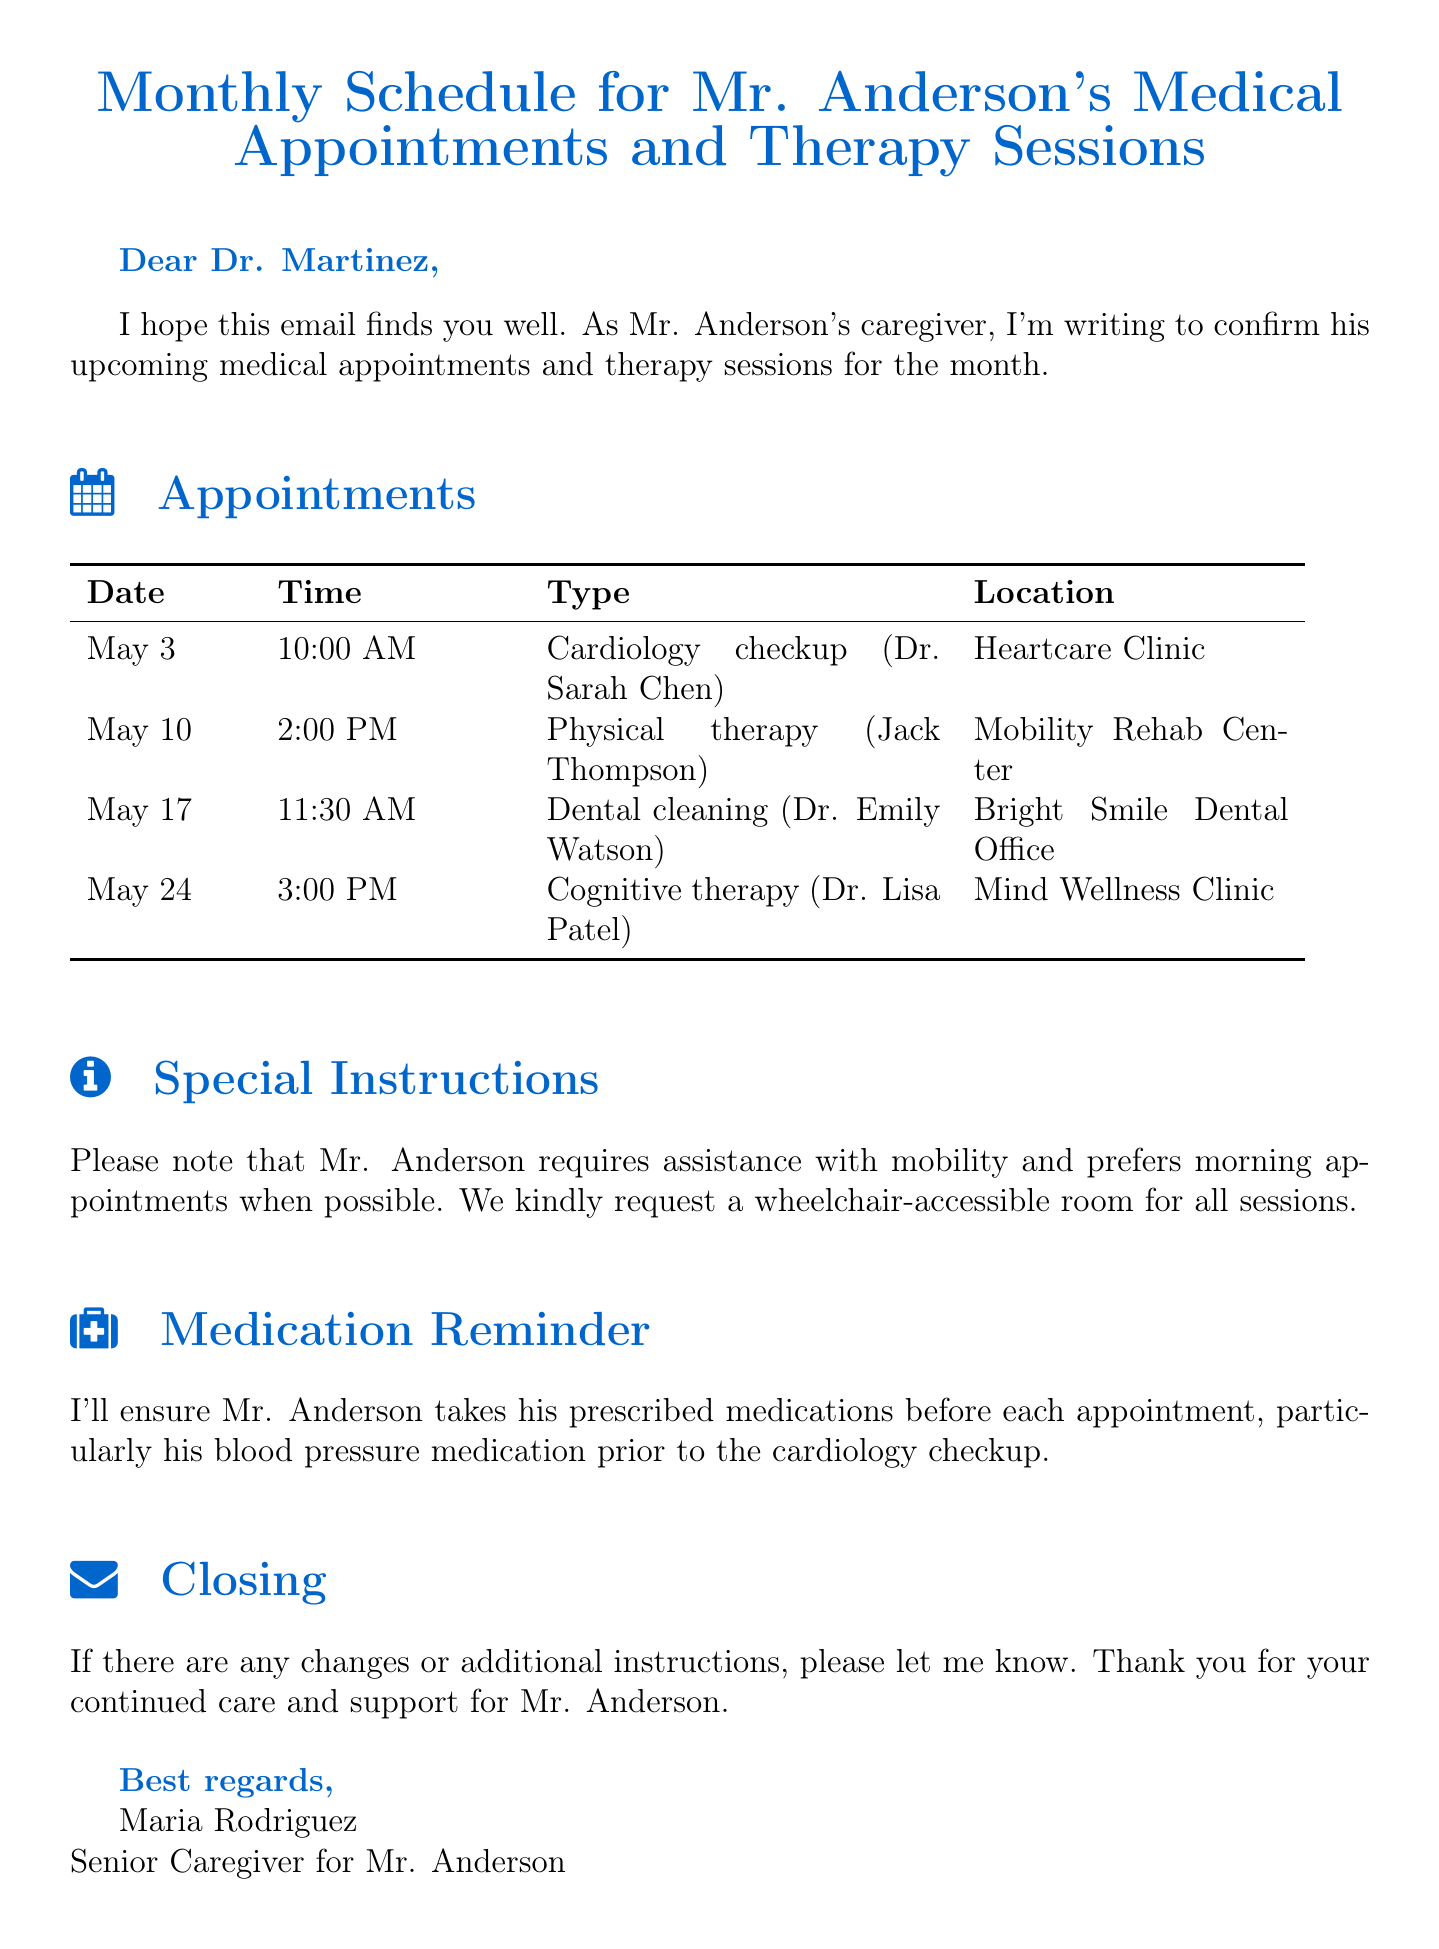What is the date of the cardiology checkup? The date for the cardiology checkup is mentioned in the appointments section of the document.
Answer: May 3 Who is the therapist for the physical therapy session? The document specifies the therapist's name for the physical therapy session.
Answer: Jack Thompson What time is the dental cleaning appointment scheduled? The document provides the time for the dental cleaning appointment in the appointments list.
Answer: 11:30 AM What special accommodation does Mr. Anderson require for his sessions? The document outlines specific accommodations requested for Mr. Anderson's appointments.
Answer: Wheelchair-accessible room What medication is explicitly mentioned to be taken before the cardiology checkup? The document states which medication should be taken before the cardiology checkup appointment.
Answer: Blood pressure medication How many appointments are scheduled for Mr. Anderson in May? The appointments section lists all scheduled appointments, which can be counted for the total.
Answer: Four What is the closing statement of the email? The document includes the closing statement addressing any changes or additional instructions.
Answer: Thank you for your continued care and support for Mr. Anderson What is the name of the dentist for the dental cleaning appointment? The document specifies the dentist's name associated with the dental cleaning appointment.
Answer: Dr. Emily Watson 